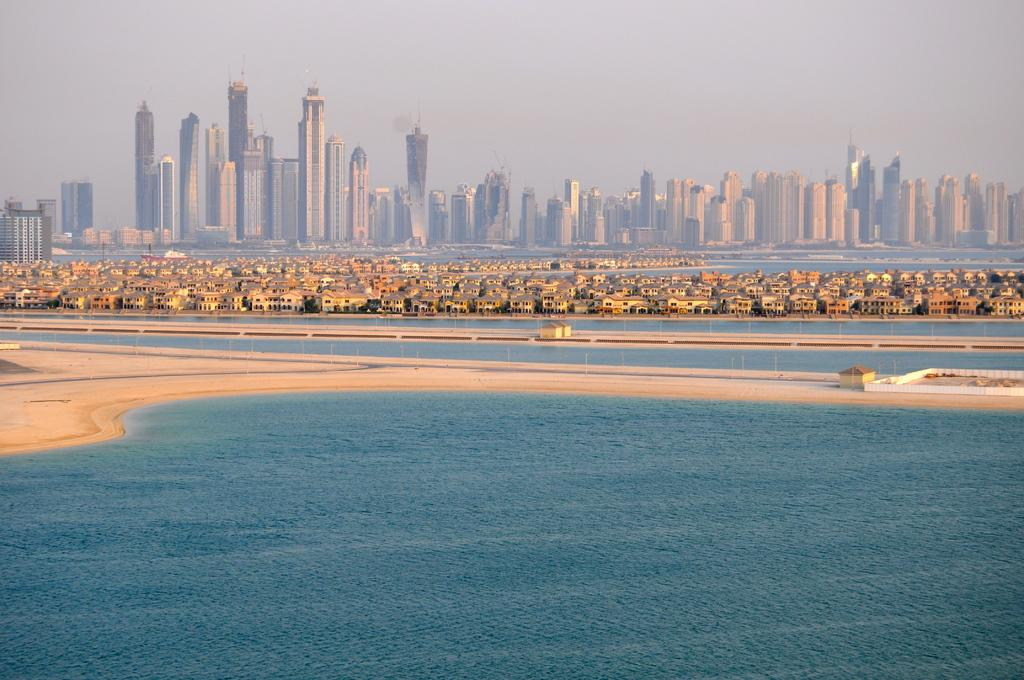What type of environment is depicted in the image? The image features water and sand, suggesting a beach or coastal setting. What type of structures can be seen in the image? There are buildings visible in the image. What type of behavior can be observed in the goldfish in the image? There are no goldfish present in the image. How does the cow interact with the water in the image? There are no cows present in the image. 